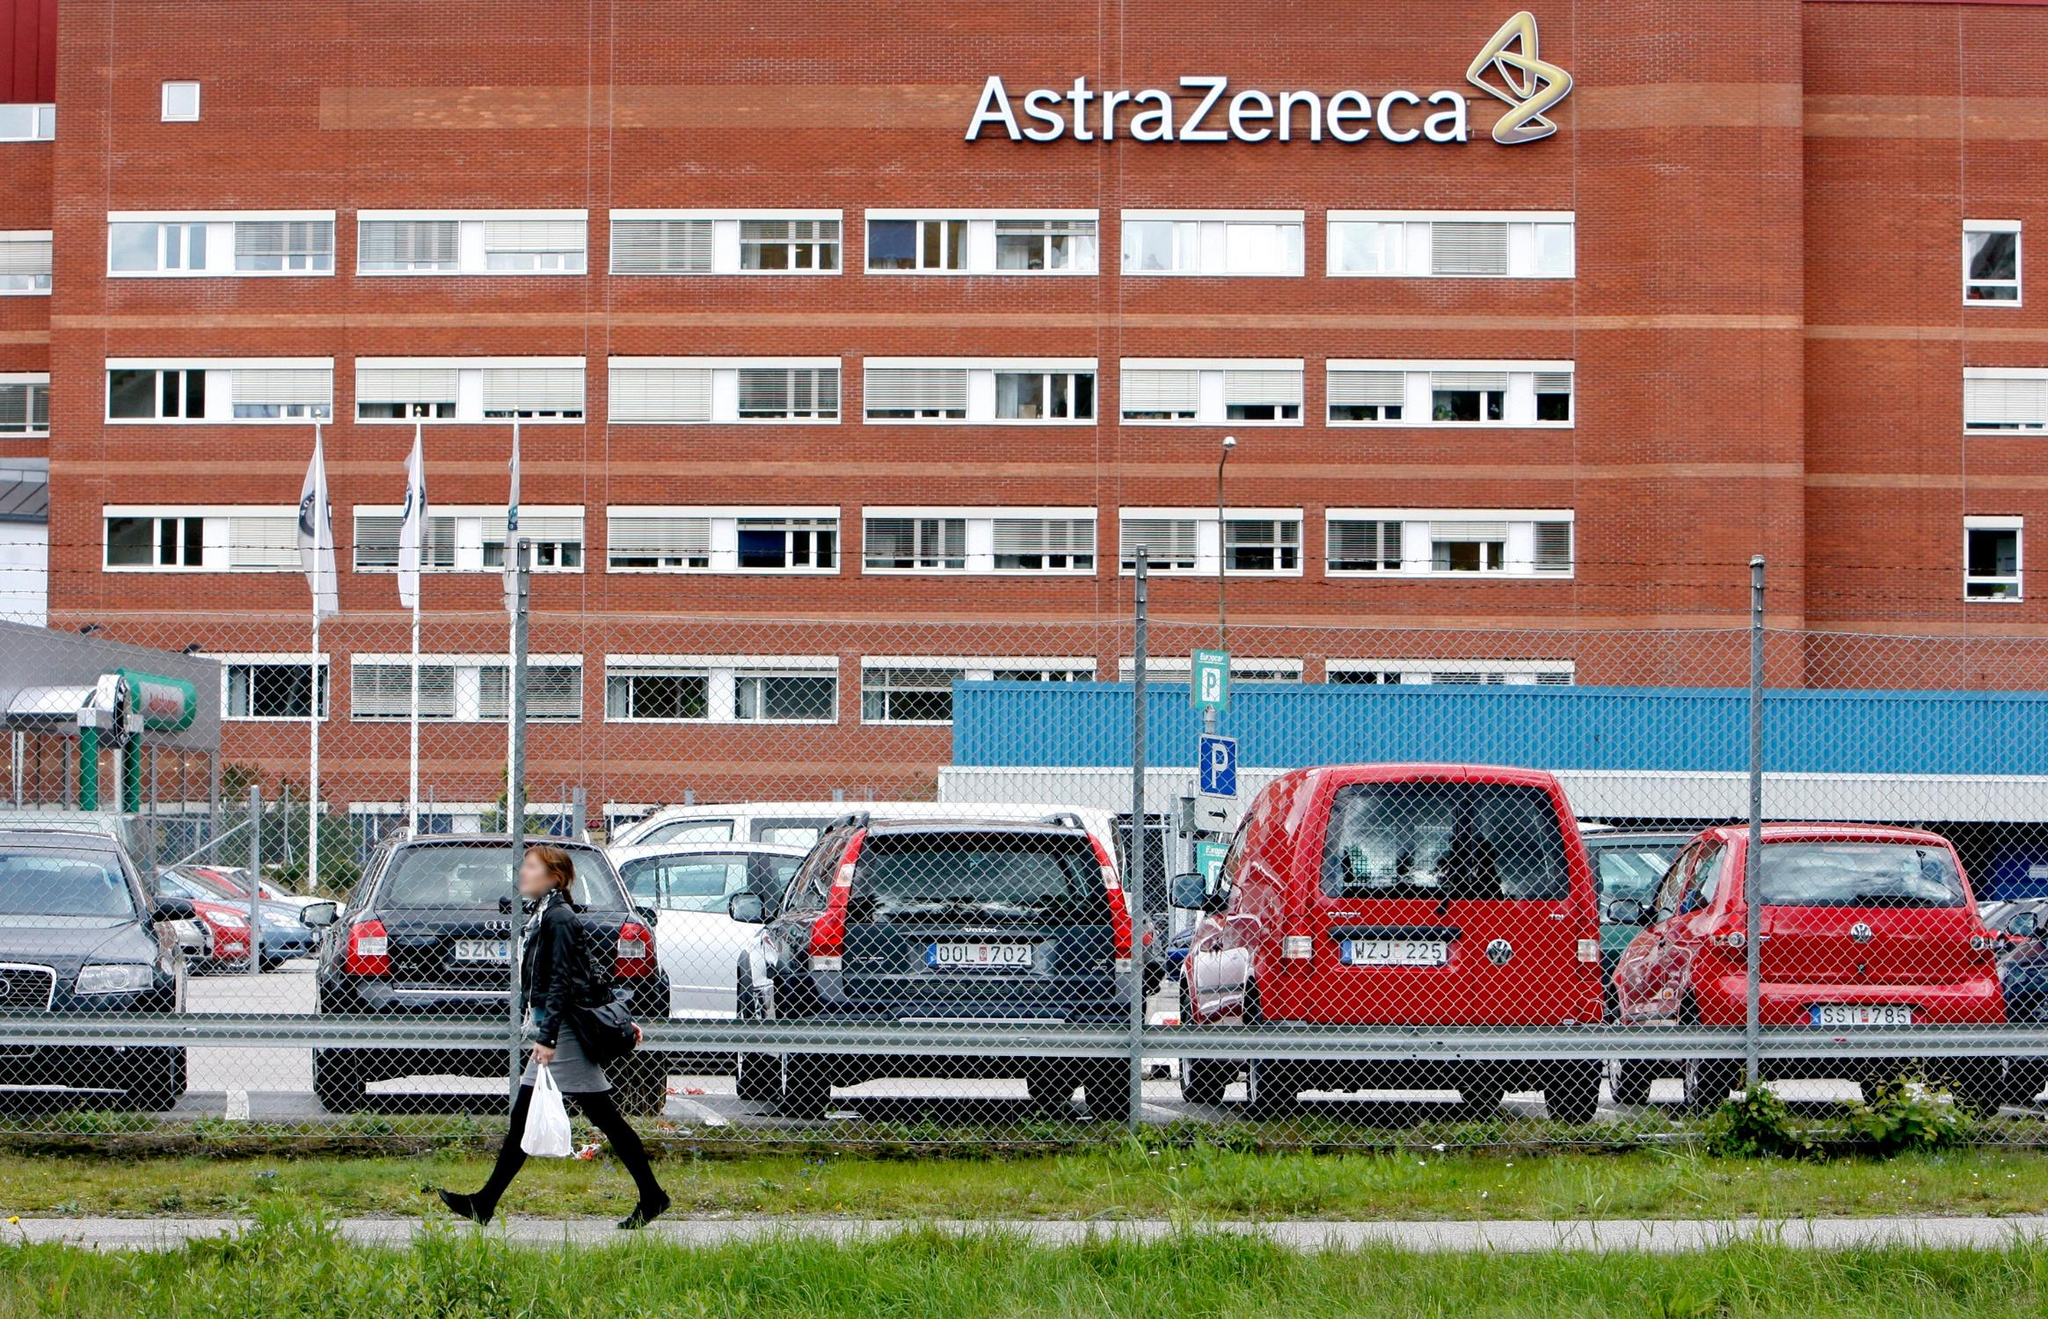What can you infer about the daily activities at this building based on the scene? From the image, it’s clear that the AstraZeneca building is a hive of activity. The busy parking lot with multiple vehicles suggests a high volume of staff and visitors, indicative of a bustling work environment. The presence of a solitary figure walking by implies regular foot traffic, likely employees going about their daily routines or visitors arriving for meetings. The overall ambiance, marked by orderliness and vitality, suggests a professional setting focused on important work, potentially research, administrative tasks, or business operations. 